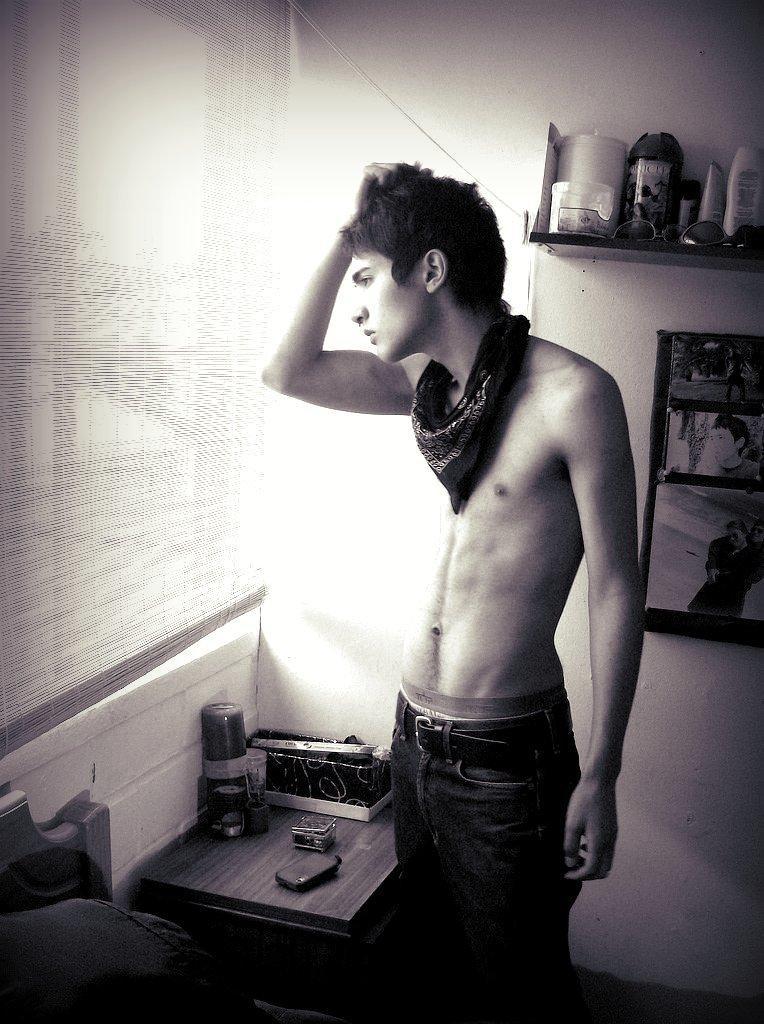Could you give a brief overview of what you see in this image? In this picture we can see a man standing and looking into the window in front of the person there is a table on that we have Bottles And wallet and some tissues backside some photo frames are been placed to the wall. 